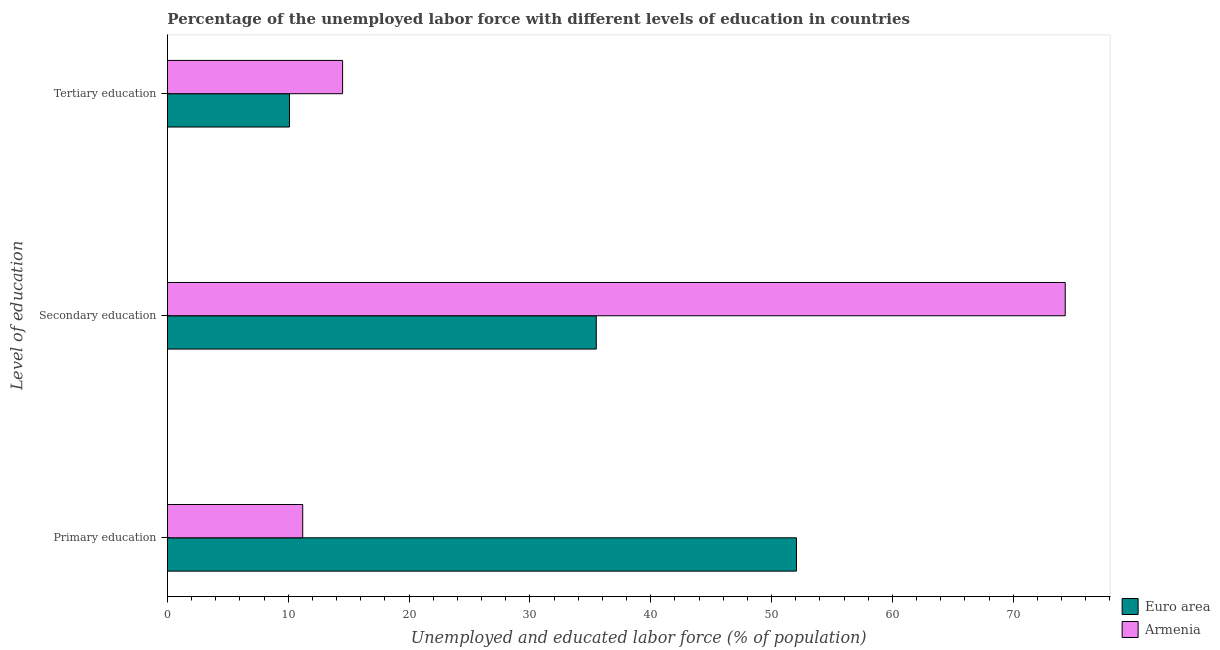How many different coloured bars are there?
Offer a very short reply. 2. How many groups of bars are there?
Your response must be concise. 3. How many bars are there on the 2nd tick from the top?
Your answer should be compact. 2. What is the label of the 2nd group of bars from the top?
Keep it short and to the point. Secondary education. What is the percentage of labor force who received secondary education in Armenia?
Ensure brevity in your answer.  74.3. Across all countries, what is the maximum percentage of labor force who received primary education?
Make the answer very short. 52.06. Across all countries, what is the minimum percentage of labor force who received secondary education?
Offer a very short reply. 35.49. What is the total percentage of labor force who received primary education in the graph?
Your answer should be very brief. 63.26. What is the difference between the percentage of labor force who received primary education in Euro area and that in Armenia?
Ensure brevity in your answer.  40.86. What is the difference between the percentage of labor force who received primary education in Euro area and the percentage of labor force who received tertiary education in Armenia?
Your answer should be compact. 37.56. What is the average percentage of labor force who received secondary education per country?
Keep it short and to the point. 54.9. What is the difference between the percentage of labor force who received tertiary education and percentage of labor force who received secondary education in Euro area?
Ensure brevity in your answer.  -25.39. What is the ratio of the percentage of labor force who received secondary education in Euro area to that in Armenia?
Your answer should be compact. 0.48. Is the difference between the percentage of labor force who received primary education in Euro area and Armenia greater than the difference between the percentage of labor force who received tertiary education in Euro area and Armenia?
Provide a succinct answer. Yes. What is the difference between the highest and the second highest percentage of labor force who received tertiary education?
Offer a very short reply. 4.4. What is the difference between the highest and the lowest percentage of labor force who received primary education?
Offer a very short reply. 40.86. In how many countries, is the percentage of labor force who received secondary education greater than the average percentage of labor force who received secondary education taken over all countries?
Your response must be concise. 1. Is the sum of the percentage of labor force who received primary education in Euro area and Armenia greater than the maximum percentage of labor force who received secondary education across all countries?
Your response must be concise. No. What does the 1st bar from the top in Primary education represents?
Give a very brief answer. Armenia. What does the 2nd bar from the bottom in Secondary education represents?
Keep it short and to the point. Armenia. Is it the case that in every country, the sum of the percentage of labor force who received primary education and percentage of labor force who received secondary education is greater than the percentage of labor force who received tertiary education?
Your response must be concise. Yes. How many countries are there in the graph?
Ensure brevity in your answer.  2. Are the values on the major ticks of X-axis written in scientific E-notation?
Give a very brief answer. No. Does the graph contain any zero values?
Your answer should be very brief. No. What is the title of the graph?
Your answer should be very brief. Percentage of the unemployed labor force with different levels of education in countries. Does "United Kingdom" appear as one of the legend labels in the graph?
Provide a succinct answer. No. What is the label or title of the X-axis?
Make the answer very short. Unemployed and educated labor force (% of population). What is the label or title of the Y-axis?
Provide a succinct answer. Level of education. What is the Unemployed and educated labor force (% of population) of Euro area in Primary education?
Provide a short and direct response. 52.06. What is the Unemployed and educated labor force (% of population) in Armenia in Primary education?
Provide a short and direct response. 11.2. What is the Unemployed and educated labor force (% of population) in Euro area in Secondary education?
Provide a succinct answer. 35.49. What is the Unemployed and educated labor force (% of population) in Armenia in Secondary education?
Make the answer very short. 74.3. What is the Unemployed and educated labor force (% of population) of Euro area in Tertiary education?
Provide a succinct answer. 10.1. Across all Level of education, what is the maximum Unemployed and educated labor force (% of population) in Euro area?
Provide a short and direct response. 52.06. Across all Level of education, what is the maximum Unemployed and educated labor force (% of population) in Armenia?
Your answer should be compact. 74.3. Across all Level of education, what is the minimum Unemployed and educated labor force (% of population) of Euro area?
Your answer should be very brief. 10.1. Across all Level of education, what is the minimum Unemployed and educated labor force (% of population) of Armenia?
Your answer should be very brief. 11.2. What is the total Unemployed and educated labor force (% of population) of Euro area in the graph?
Your answer should be very brief. 97.66. What is the difference between the Unemployed and educated labor force (% of population) of Euro area in Primary education and that in Secondary education?
Your answer should be very brief. 16.57. What is the difference between the Unemployed and educated labor force (% of population) in Armenia in Primary education and that in Secondary education?
Ensure brevity in your answer.  -63.1. What is the difference between the Unemployed and educated labor force (% of population) of Euro area in Primary education and that in Tertiary education?
Offer a very short reply. 41.96. What is the difference between the Unemployed and educated labor force (% of population) of Armenia in Primary education and that in Tertiary education?
Make the answer very short. -3.3. What is the difference between the Unemployed and educated labor force (% of population) in Euro area in Secondary education and that in Tertiary education?
Provide a succinct answer. 25.39. What is the difference between the Unemployed and educated labor force (% of population) in Armenia in Secondary education and that in Tertiary education?
Your answer should be compact. 59.8. What is the difference between the Unemployed and educated labor force (% of population) in Euro area in Primary education and the Unemployed and educated labor force (% of population) in Armenia in Secondary education?
Provide a succinct answer. -22.24. What is the difference between the Unemployed and educated labor force (% of population) in Euro area in Primary education and the Unemployed and educated labor force (% of population) in Armenia in Tertiary education?
Keep it short and to the point. 37.56. What is the difference between the Unemployed and educated labor force (% of population) in Euro area in Secondary education and the Unemployed and educated labor force (% of population) in Armenia in Tertiary education?
Give a very brief answer. 20.99. What is the average Unemployed and educated labor force (% of population) in Euro area per Level of education?
Provide a short and direct response. 32.55. What is the average Unemployed and educated labor force (% of population) of Armenia per Level of education?
Give a very brief answer. 33.33. What is the difference between the Unemployed and educated labor force (% of population) of Euro area and Unemployed and educated labor force (% of population) of Armenia in Primary education?
Your answer should be compact. 40.86. What is the difference between the Unemployed and educated labor force (% of population) of Euro area and Unemployed and educated labor force (% of population) of Armenia in Secondary education?
Provide a succinct answer. -38.81. What is the difference between the Unemployed and educated labor force (% of population) of Euro area and Unemployed and educated labor force (% of population) of Armenia in Tertiary education?
Offer a terse response. -4.4. What is the ratio of the Unemployed and educated labor force (% of population) of Euro area in Primary education to that in Secondary education?
Offer a very short reply. 1.47. What is the ratio of the Unemployed and educated labor force (% of population) in Armenia in Primary education to that in Secondary education?
Provide a short and direct response. 0.15. What is the ratio of the Unemployed and educated labor force (% of population) of Euro area in Primary education to that in Tertiary education?
Your answer should be compact. 5.15. What is the ratio of the Unemployed and educated labor force (% of population) in Armenia in Primary education to that in Tertiary education?
Offer a terse response. 0.77. What is the ratio of the Unemployed and educated labor force (% of population) in Euro area in Secondary education to that in Tertiary education?
Give a very brief answer. 3.51. What is the ratio of the Unemployed and educated labor force (% of population) in Armenia in Secondary education to that in Tertiary education?
Ensure brevity in your answer.  5.12. What is the difference between the highest and the second highest Unemployed and educated labor force (% of population) in Euro area?
Your answer should be compact. 16.57. What is the difference between the highest and the second highest Unemployed and educated labor force (% of population) in Armenia?
Provide a short and direct response. 59.8. What is the difference between the highest and the lowest Unemployed and educated labor force (% of population) of Euro area?
Make the answer very short. 41.96. What is the difference between the highest and the lowest Unemployed and educated labor force (% of population) in Armenia?
Give a very brief answer. 63.1. 